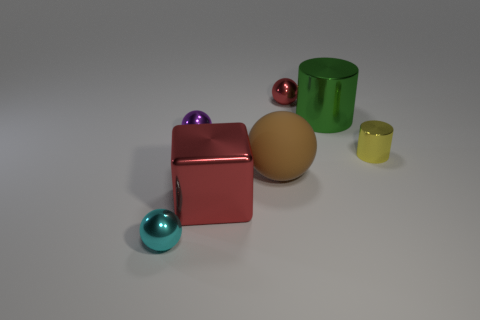What might be the context or setting of this image? The objects are arranged as if they are part of a still life composition, possibly for a study of color, shapes, and shadows, likely set in an indoor environment with controlled lighting. 